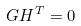<formula> <loc_0><loc_0><loc_500><loc_500>G H ^ { T } = 0</formula> 